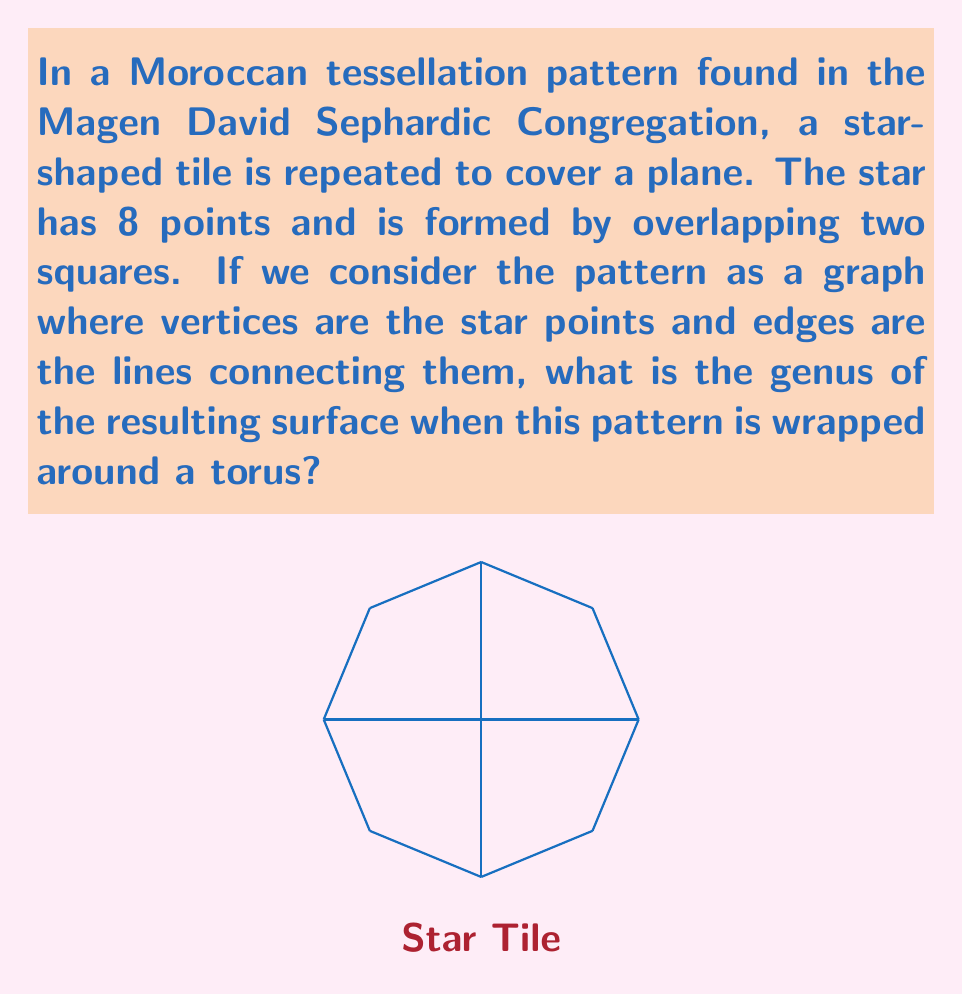What is the answer to this math problem? Let's approach this step-by-step:

1) First, we need to understand what determines the genus of a surface. The Euler characteristic $\chi$ of a surface is related to its genus $g$ by the formula:

   $$\chi = 2 - 2g$$

2) For a graph on a surface, the Euler characteristic is given by:

   $$\chi = V - E + F$$

   where $V$ is the number of vertices, $E$ is the number of edges, and $F$ is the number of faces.

3) In our tessellation:
   - Each star tile has 8 vertices.
   - Each star tile has 12 edges (8 outer edges + 4 inner edges).
   - Each star tile creates 5 faces (4 triangles + 1 square in the center).

4) When we wrap this pattern around a torus, some vertices, edges, and faces will be shared between tiles. Let's consider a 2x2 grid of tiles that wraps around the torus:

   - Vertices: There are 16 unique vertices (8 per tile, but half are shared).
   - Edges: There are 32 unique edges (12 per tile, but 1/3 are shared).
   - Faces: There are 20 unique faces (5 per tile).

5) Now we can calculate the Euler characteristic:

   $$\chi = V - E + F = 16 - 32 + 20 = 4$$

6) Using the formula from step 1:

   $$4 = 2 - 2g$$
   $$2g = -2$$
   $$g = -1$$

7) However, the genus must be a non-negative integer. The negative result indicates that our initial assumption of a 2x2 grid was incorrect.

8) Let's try a 3x3 grid instead:

   - Vertices: 36 (9 tiles, 4 unique vertices per tile)
   - Edges: 108 (9 tiles, 12 edges per tile)
   - Faces: 45 (9 tiles, 5 faces per tile)

9) Calculating again:

   $$\chi = V - E + F = 36 - 108 + 45 = -27$$

10) Using the formula:

    $$-27 = 2 - 2g$$
    $$2g = 29$$
    $$g = \frac{29}{2}$$

11) Since $g$ must be an integer, we need to increase our grid size to 4x4:

    - Vertices: 64
    - Edges: 192
    - Faces: 80

12) Final calculation:

    $$\chi = 64 - 192 + 80 = -48$$
    $$-48 = 2 - 2g$$
    $$2g = 50$$
    $$g = 25$$
Answer: 25 